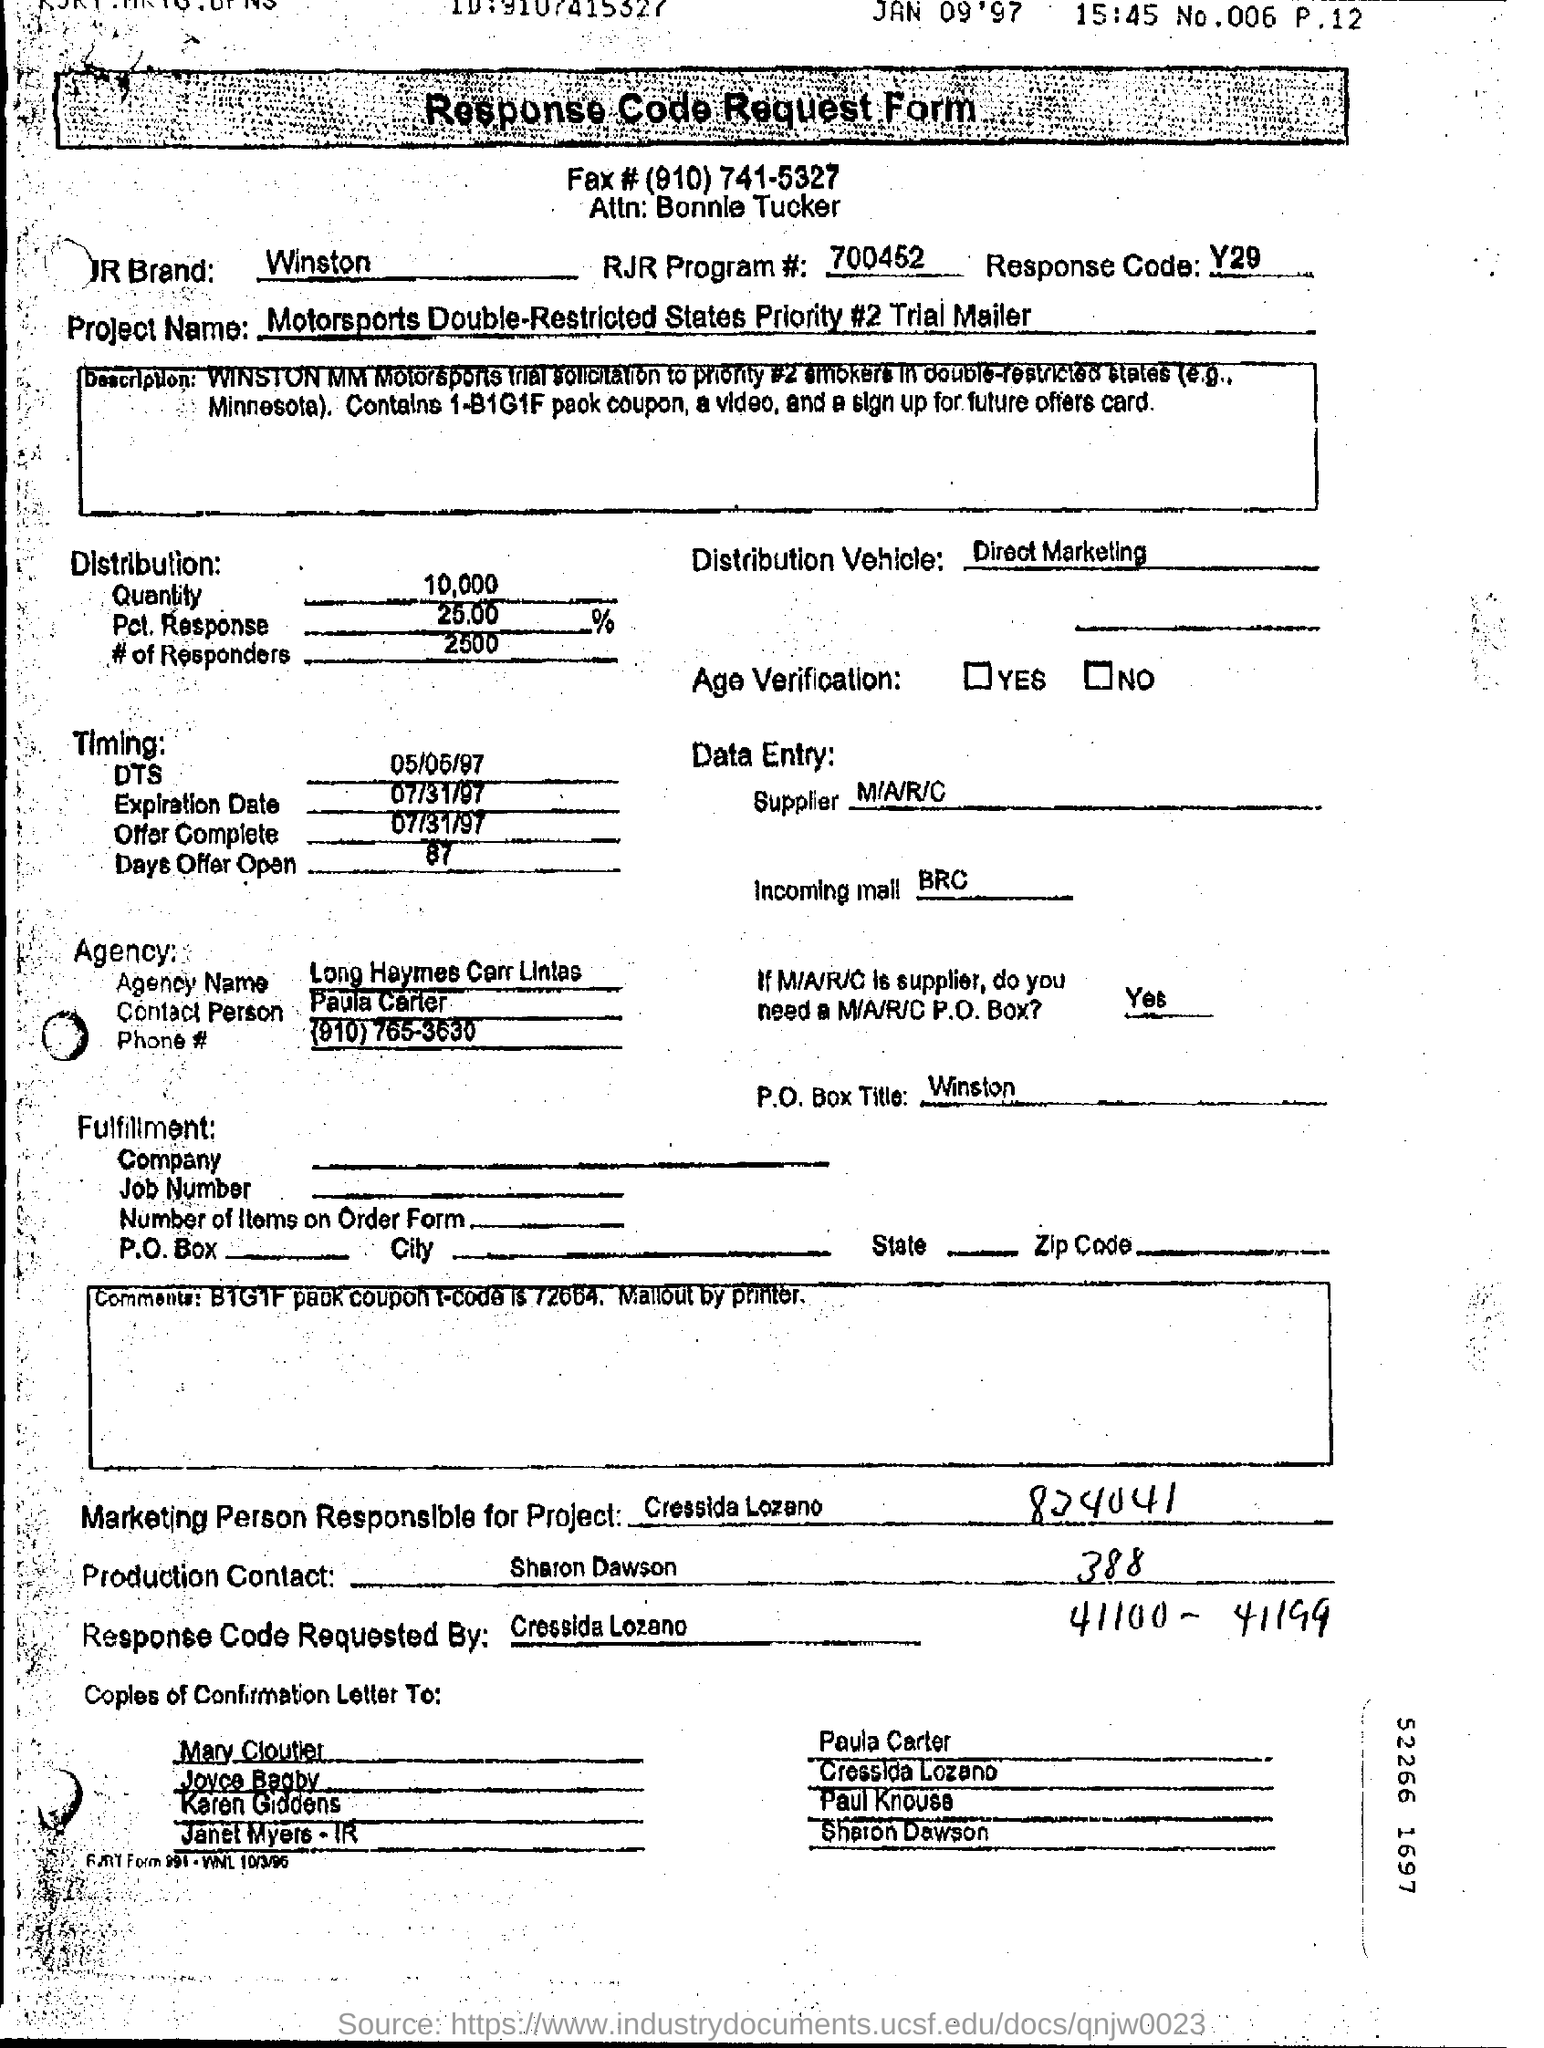What is the Agency Name ?
Provide a succinct answer. Long Haymes Carr Lintas. 